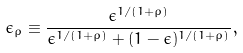Convert formula to latex. <formula><loc_0><loc_0><loc_500><loc_500>\epsilon _ { \rho } \equiv \frac { \epsilon ^ { 1 / ( 1 + \rho ) } } { \epsilon ^ { 1 / ( 1 + \rho ) } + ( 1 - \epsilon ) ^ { 1 / ( 1 + \rho ) } } ,</formula> 